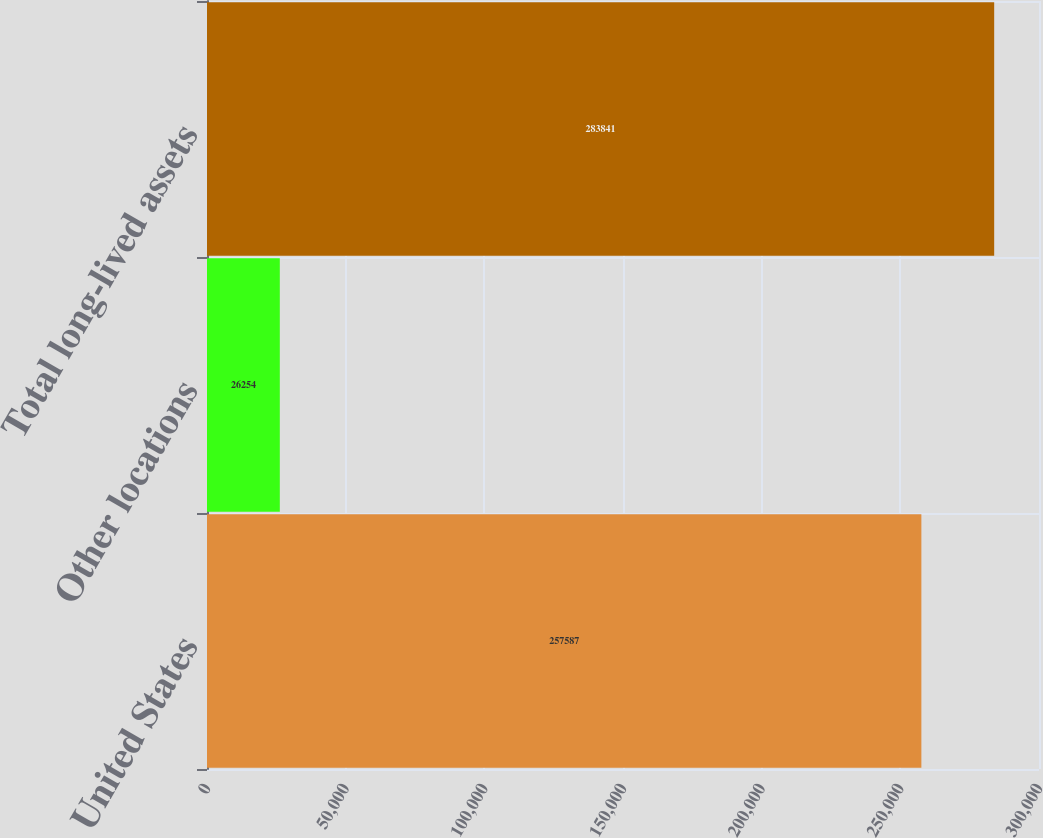<chart> <loc_0><loc_0><loc_500><loc_500><bar_chart><fcel>United States<fcel>Other locations<fcel>Total long-lived assets<nl><fcel>257587<fcel>26254<fcel>283841<nl></chart> 